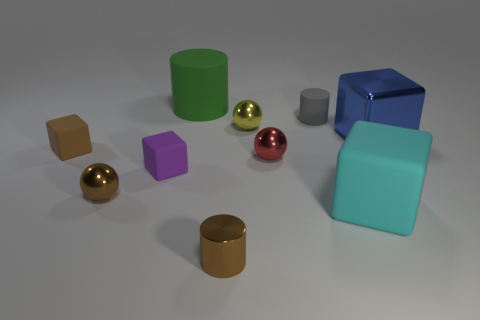Can you tell me what the largest object in the image is? The largest object in the image appears to be the green cylinder. It is noticeably taller and wider than the other objects displayed. 